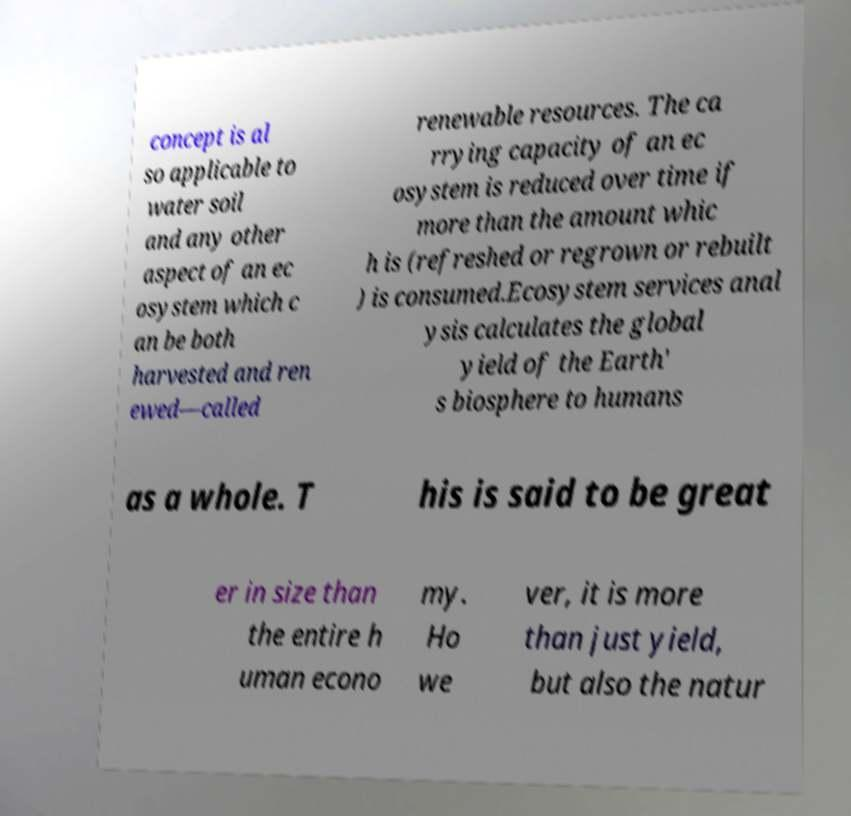What messages or text are displayed in this image? I need them in a readable, typed format. concept is al so applicable to water soil and any other aspect of an ec osystem which c an be both harvested and ren ewed—called renewable resources. The ca rrying capacity of an ec osystem is reduced over time if more than the amount whic h is (refreshed or regrown or rebuilt ) is consumed.Ecosystem services anal ysis calculates the global yield of the Earth' s biosphere to humans as a whole. T his is said to be great er in size than the entire h uman econo my. Ho we ver, it is more than just yield, but also the natur 